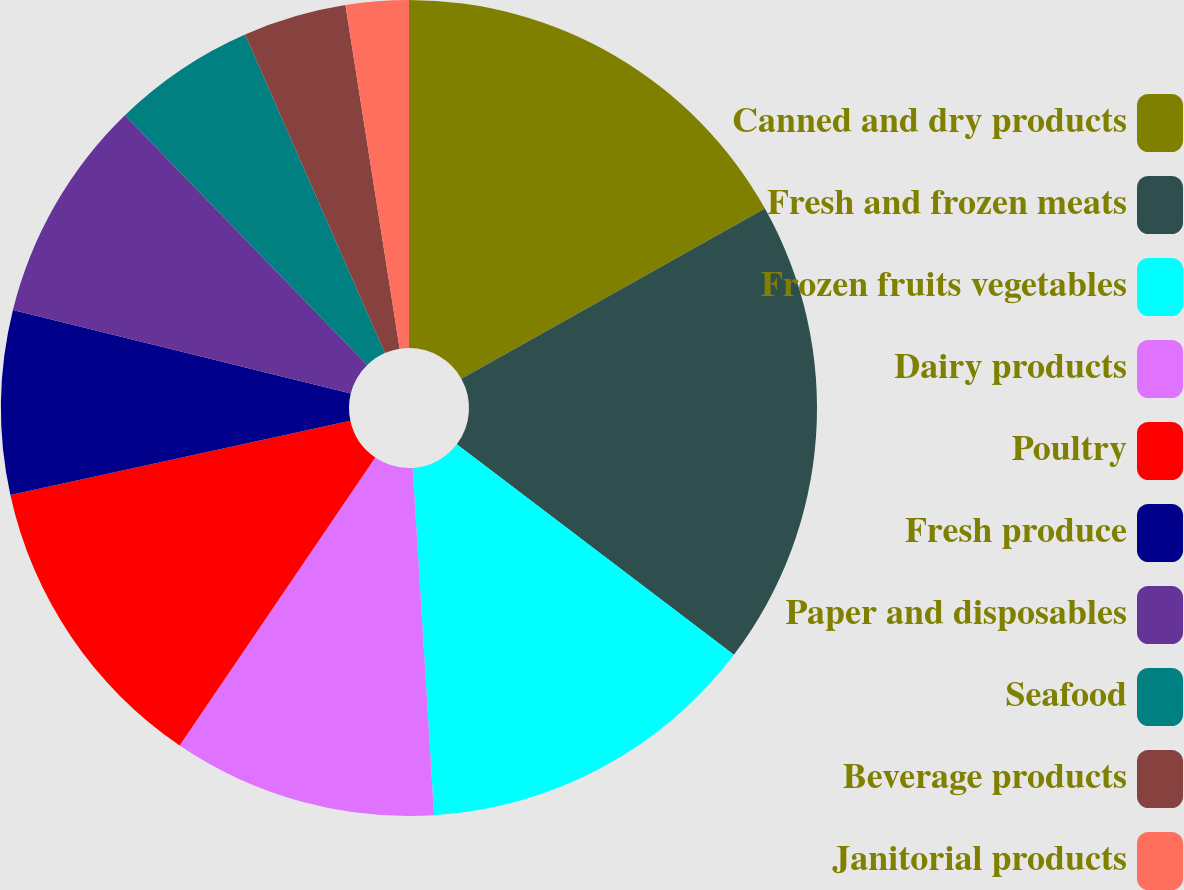<chart> <loc_0><loc_0><loc_500><loc_500><pie_chart><fcel>Canned and dry products<fcel>Fresh and frozen meats<fcel>Frozen fruits vegetables<fcel>Dairy products<fcel>Poultry<fcel>Fresh produce<fcel>Paper and disposables<fcel>Seafood<fcel>Beverage products<fcel>Janitorial products<nl><fcel>16.87%<fcel>18.47%<fcel>13.68%<fcel>10.48%<fcel>12.08%<fcel>7.28%<fcel>8.88%<fcel>5.68%<fcel>4.09%<fcel>2.49%<nl></chart> 